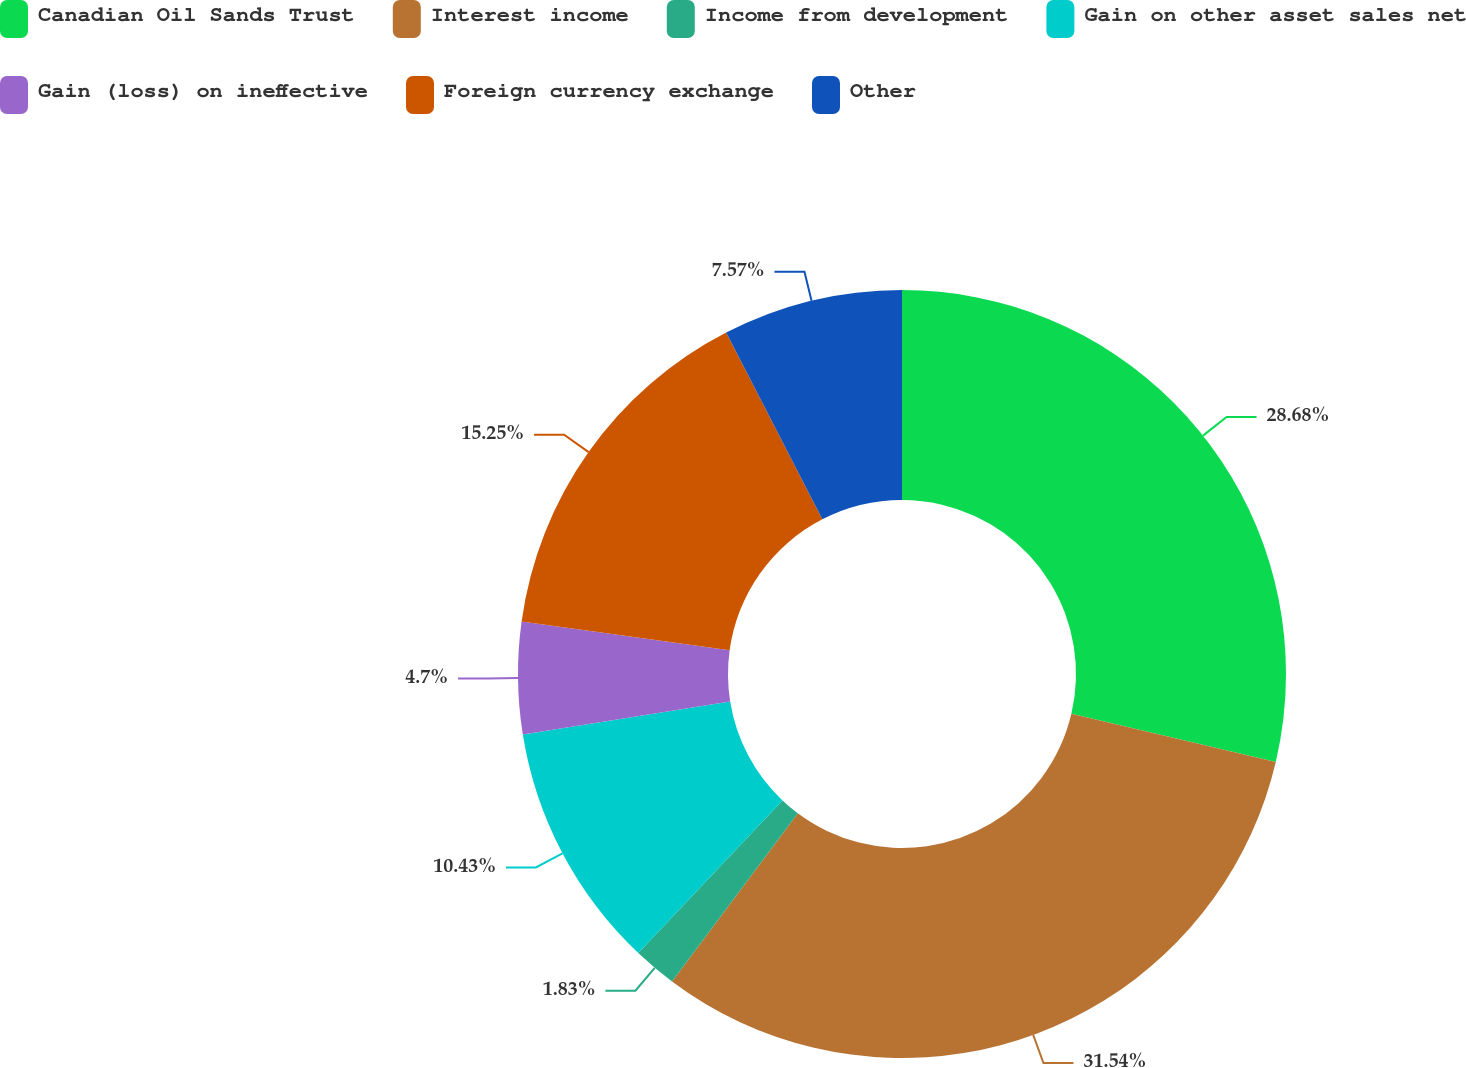Convert chart. <chart><loc_0><loc_0><loc_500><loc_500><pie_chart><fcel>Canadian Oil Sands Trust<fcel>Interest income<fcel>Income from development<fcel>Gain on other asset sales net<fcel>Gain (loss) on ineffective<fcel>Foreign currency exchange<fcel>Other<nl><fcel>28.68%<fcel>31.54%<fcel>1.83%<fcel>10.43%<fcel>4.7%<fcel>15.25%<fcel>7.57%<nl></chart> 